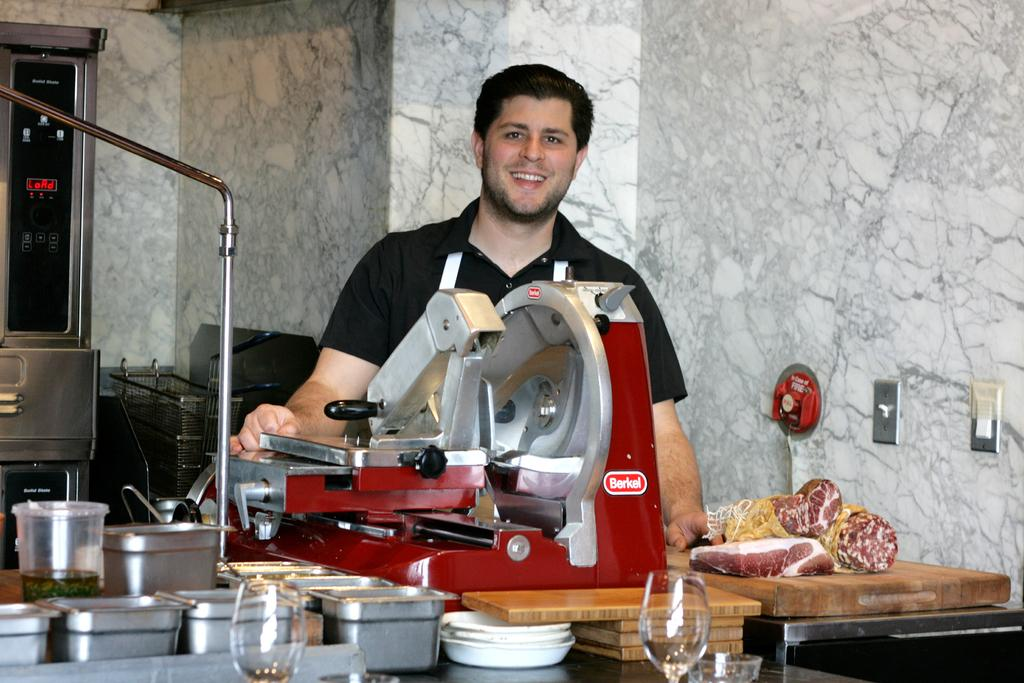<image>
Create a compact narrative representing the image presented. A smiling man stands behind a red Berkel meat slicer. 